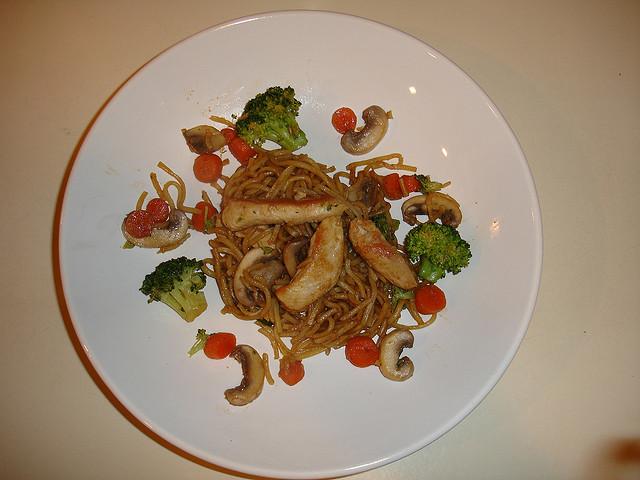Is the food healthy?
Answer briefly. Yes. Which meal of the day is this?
Keep it brief. Dinner. How many tomatoes can you see?
Short answer required. 0. Is this a hot or cold plate of food?
Keep it brief. Hot. What kind of food is on the white plate?
Give a very brief answer. Chinese. How much does the plate weight?
Keep it brief. 7 oz. How many carrots on the plate?
Write a very short answer. 0. 